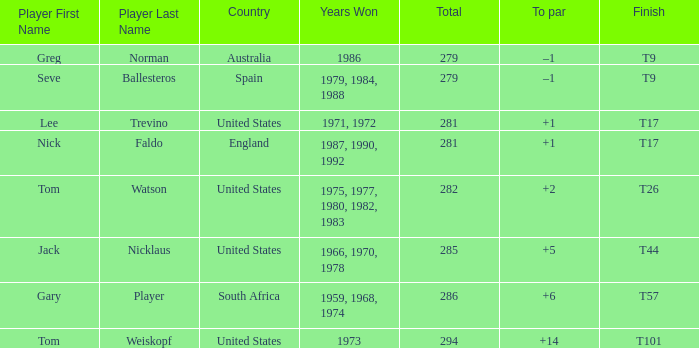Which country had a total of 282? United States. 